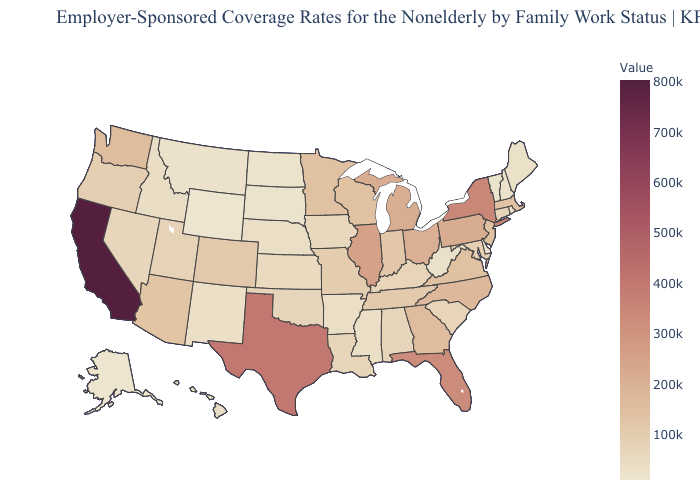Which states have the lowest value in the USA?
Answer briefly. Alaska. Which states have the highest value in the USA?
Give a very brief answer. California. Does the map have missing data?
Quick response, please. No. Which states hav the highest value in the West?
Concise answer only. California. Does Texas have the lowest value in the USA?
Be succinct. No. 